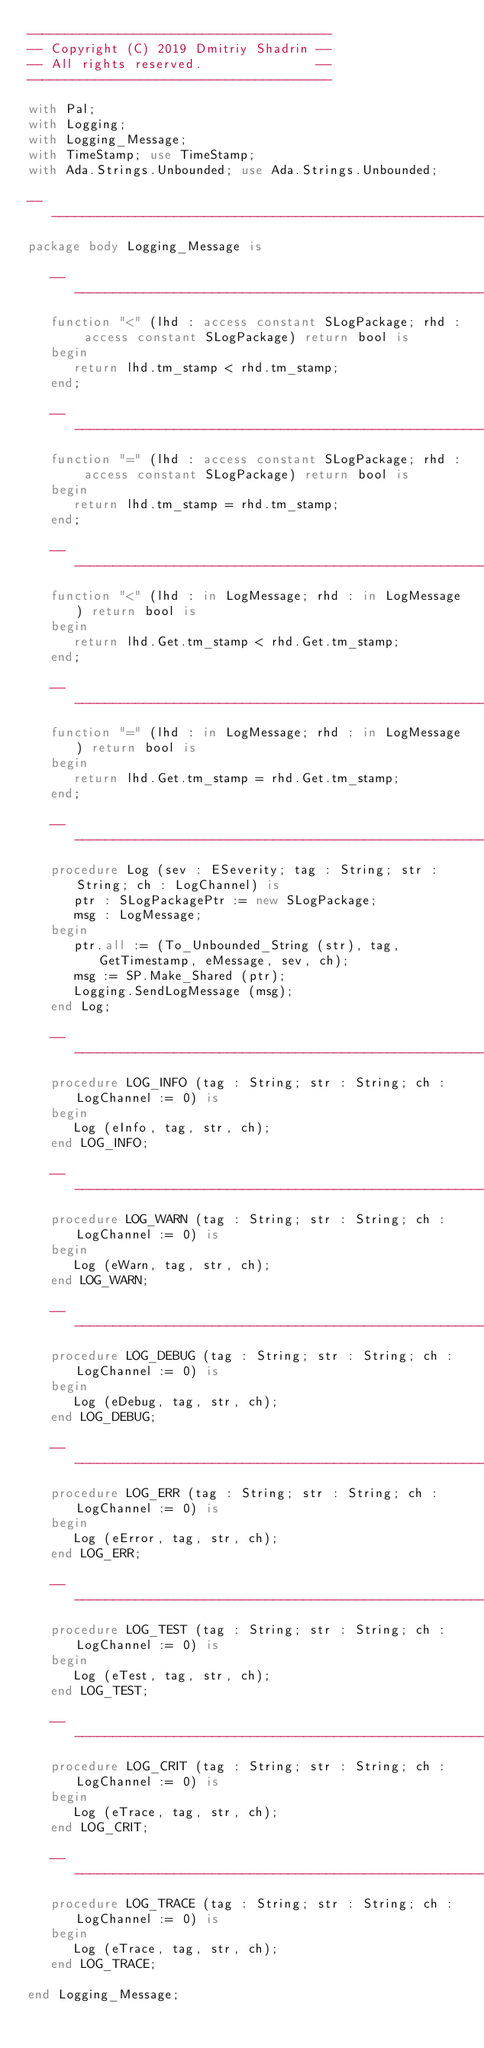<code> <loc_0><loc_0><loc_500><loc_500><_Ada_>----------------------------------------
-- Copyright (C) 2019 Dmitriy Shadrin --
-- All rights reserved.               --
----------------------------------------

with Pal;
with Logging;
with Logging_Message;
with TimeStamp; use TimeStamp;
with Ada.Strings.Unbounded; use Ada.Strings.Unbounded;

--------------------------------------------------------------------------------
package body Logging_Message is

   -----------------------------------------------------------------------------
   function "<" (lhd : access constant SLogPackage; rhd : access constant SLogPackage) return bool is
   begin
      return lhd.tm_stamp < rhd.tm_stamp;
   end;
   
   -----------------------------------------------------------------------------
   function "=" (lhd : access constant SLogPackage; rhd : access constant SLogPackage) return bool is
   begin
      return lhd.tm_stamp = rhd.tm_stamp;
   end;
      
   -----------------------------------------------------------------------------
   function "<" (lhd : in LogMessage; rhd : in LogMessage) return bool is
   begin
      return lhd.Get.tm_stamp < rhd.Get.tm_stamp;
   end;
   
   -----------------------------------------------------------------------------
   function "=" (lhd : in LogMessage; rhd : in LogMessage) return bool is
   begin
      return lhd.Get.tm_stamp = rhd.Get.tm_stamp;
   end;

   -----------------------------------------------------------------------------
   procedure Log (sev : ESeverity; tag : String; str : String; ch : LogChannel) is
      ptr : SLogPackagePtr := new SLogPackage;
      msg : LogMessage;
   begin
      ptr.all := (To_Unbounded_String (str), tag, GetTimestamp, eMessage, sev, ch);
      msg := SP.Make_Shared (ptr);
      Logging.SendLogMessage (msg);
   end Log;

   -----------------------------------------------------------------------------
   procedure LOG_INFO (tag : String; str : String; ch : LogChannel := 0) is
   begin
      Log (eInfo, tag, str, ch);
   end LOG_INFO;
   
   -----------------------------------------------------------------------------
   procedure LOG_WARN (tag : String; str : String; ch : LogChannel := 0) is
   begin
      Log (eWarn, tag, str, ch);
   end LOG_WARN;

   -----------------------------------------------------------------------------
   procedure LOG_DEBUG (tag : String; str : String; ch : LogChannel := 0) is
   begin
      Log (eDebug, tag, str, ch);
   end LOG_DEBUG;

   -----------------------------------------------------------------------------
   procedure LOG_ERR (tag : String; str : String; ch : LogChannel := 0) is
   begin
      Log (eError, tag, str, ch);
   end LOG_ERR;

   -----------------------------------------------------------------------------
   procedure LOG_TEST (tag : String; str : String; ch : LogChannel := 0) is
   begin
      Log (eTest, tag, str, ch);
   end LOG_TEST;

   -----------------------------------------------------------------------------
   procedure LOG_CRIT (tag : String; str : String; ch : LogChannel := 0) is
   begin
      Log (eTrace, tag, str, ch);
   end LOG_CRIT;

   -----------------------------------------------------------------------------
   procedure LOG_TRACE (tag : String; str : String; ch : LogChannel := 0) is
   begin
      Log (eTrace, tag, str, ch);
   end LOG_TRACE;

end Logging_Message;
</code> 